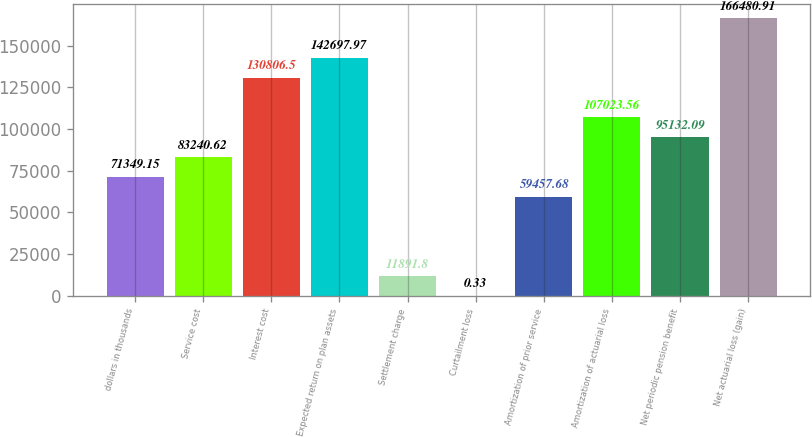Convert chart. <chart><loc_0><loc_0><loc_500><loc_500><bar_chart><fcel>dollars in thousands<fcel>Service cost<fcel>Interest cost<fcel>Expected return on plan assets<fcel>Settlement charge<fcel>Curtailment loss<fcel>Amortization of prior service<fcel>Amortization of actuarial loss<fcel>Net periodic pension benefit<fcel>Net actuarial loss (gain)<nl><fcel>71349.1<fcel>83240.6<fcel>130806<fcel>142698<fcel>11891.8<fcel>0.33<fcel>59457.7<fcel>107024<fcel>95132.1<fcel>166481<nl></chart> 